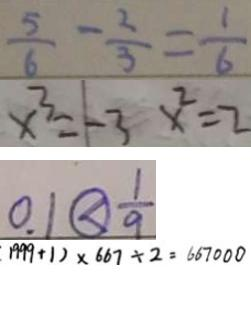<formula> <loc_0><loc_0><loc_500><loc_500>\frac { 5 } { 6 } - \frac { 2 } { 3 } = \frac { 1 } { 6 } 
 x ^ { 3 } = - 3 x ^ { 2 } = 2 
 0 . 1 \textcircled { < } \frac { 1 } { 9 } 
 1 9 9 9 + 1 ) \times 6 6 7 \div 2 = 6 6 7 0 0 0</formula> 